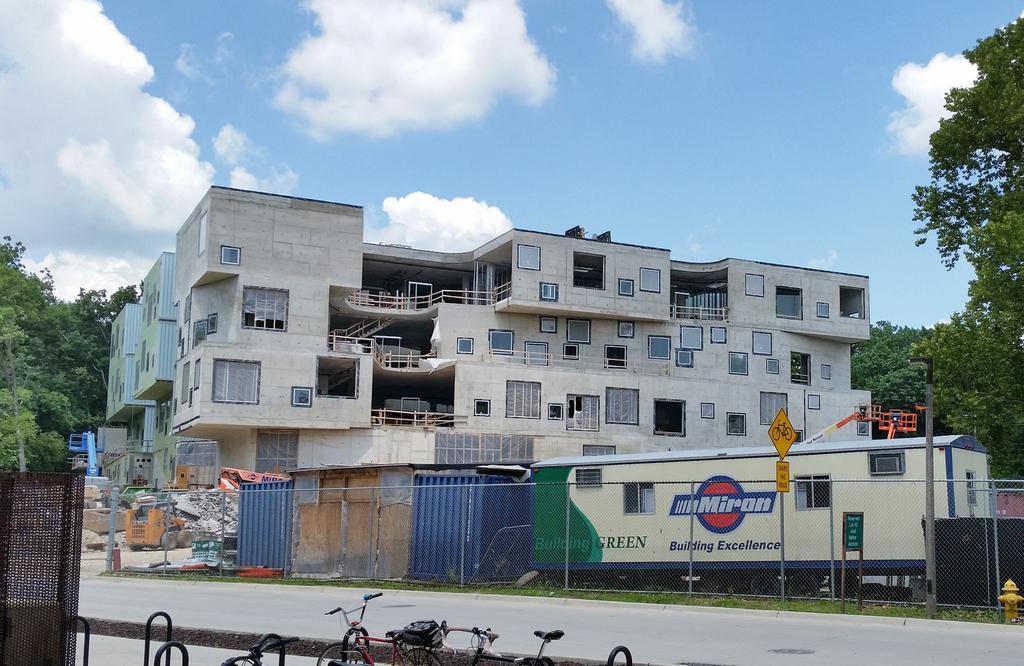In one or two sentences, can you explain what this image depicts? This picture is clicked outside. In the foreground we can see the bicycles and the metal rods. In the center we can see the text on an object which seems to be the vehicle and we can see the green grass, metal sheets, vehicles and many other objects. In the background we can see the sky with the clouds and we can see the trees and the buildings and some other items. 